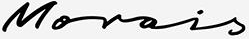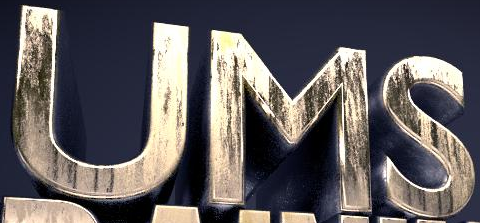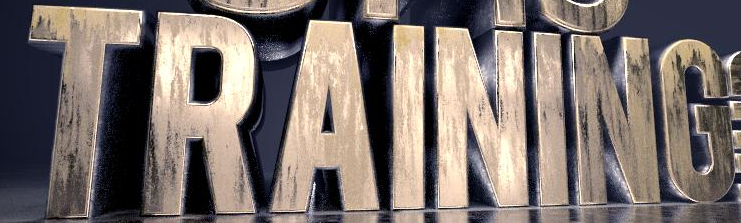Identify the words shown in these images in order, separated by a semicolon. Morois; UMS; TRAINING 